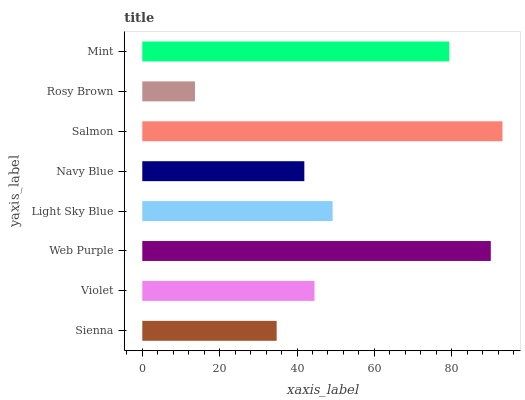Is Rosy Brown the minimum?
Answer yes or no. Yes. Is Salmon the maximum?
Answer yes or no. Yes. Is Violet the minimum?
Answer yes or no. No. Is Violet the maximum?
Answer yes or no. No. Is Violet greater than Sienna?
Answer yes or no. Yes. Is Sienna less than Violet?
Answer yes or no. Yes. Is Sienna greater than Violet?
Answer yes or no. No. Is Violet less than Sienna?
Answer yes or no. No. Is Light Sky Blue the high median?
Answer yes or no. Yes. Is Violet the low median?
Answer yes or no. Yes. Is Sienna the high median?
Answer yes or no. No. Is Sienna the low median?
Answer yes or no. No. 